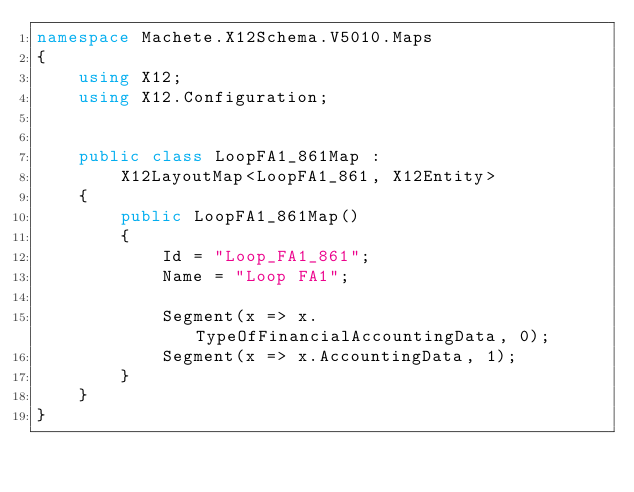<code> <loc_0><loc_0><loc_500><loc_500><_C#_>namespace Machete.X12Schema.V5010.Maps
{
    using X12;
    using X12.Configuration;


    public class LoopFA1_861Map :
        X12LayoutMap<LoopFA1_861, X12Entity>
    {
        public LoopFA1_861Map()
        {
            Id = "Loop_FA1_861";
            Name = "Loop FA1";
            
            Segment(x => x.TypeOfFinancialAccountingData, 0);
            Segment(x => x.AccountingData, 1);
        }
    }
}</code> 